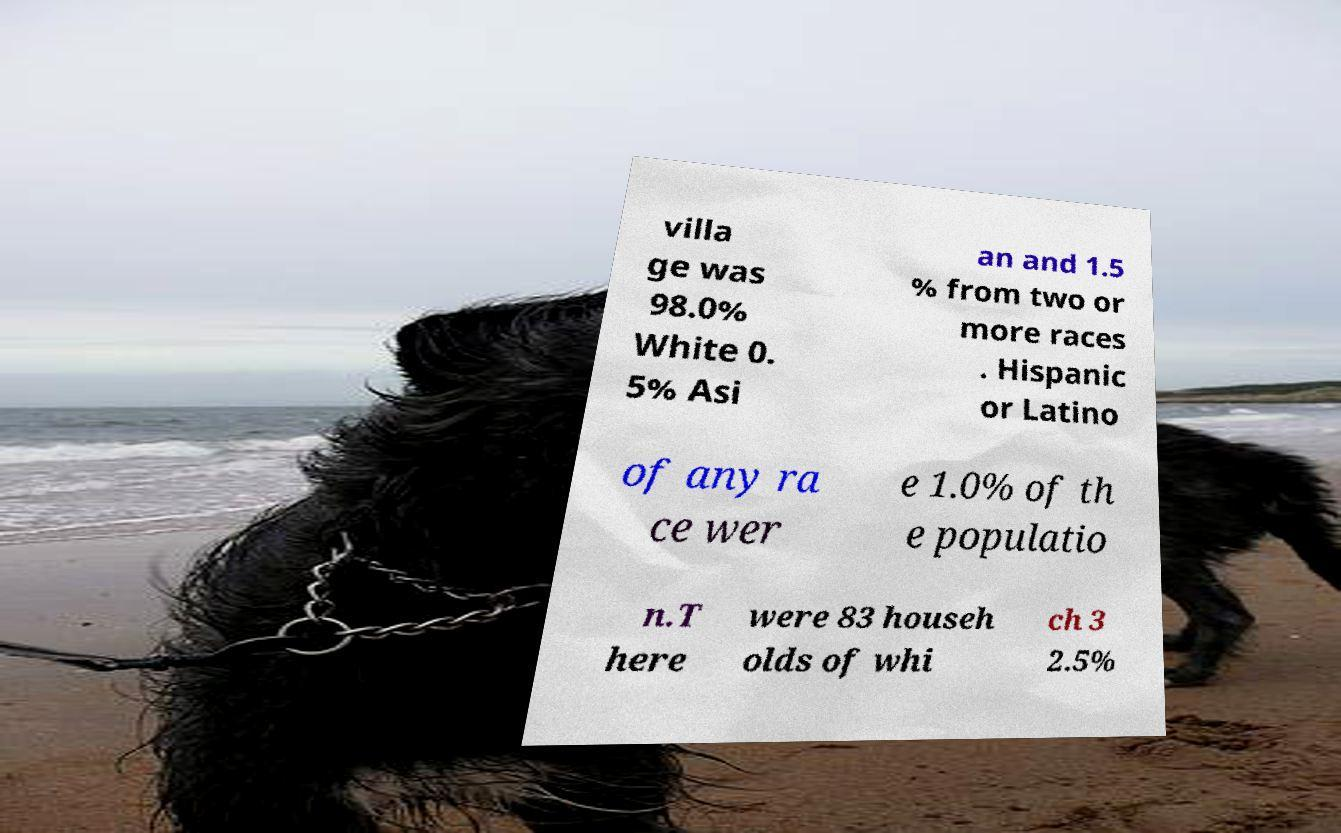Can you accurately transcribe the text from the provided image for me? villa ge was 98.0% White 0. 5% Asi an and 1.5 % from two or more races . Hispanic or Latino of any ra ce wer e 1.0% of th e populatio n.T here were 83 househ olds of whi ch 3 2.5% 